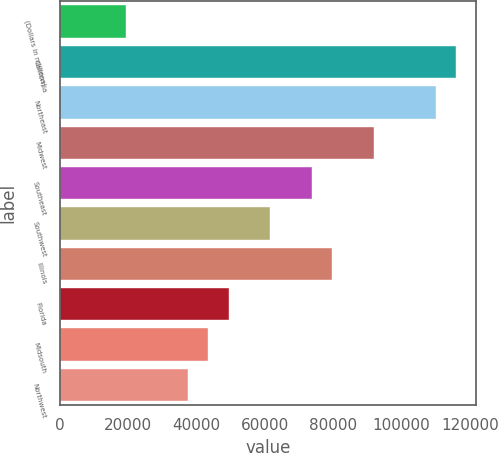<chart> <loc_0><loc_0><loc_500><loc_500><bar_chart><fcel>(Dollars in millions)<fcel>California<fcel>Northeast<fcel>Midwest<fcel>Southeast<fcel>Southwest<fcel>Illinois<fcel>Florida<fcel>Midsouth<fcel>Northwest<nl><fcel>19226.1<fcel>116085<fcel>110032<fcel>91870.5<fcel>73709.4<fcel>61602<fcel>79763.1<fcel>49494.6<fcel>43440.9<fcel>37387.2<nl></chart> 